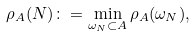<formula> <loc_0><loc_0><loc_500><loc_500>\rho _ { A } ( N ) \colon = \min _ { \omega _ { N } \subset A } \rho _ { A } ( \omega _ { N } ) ,</formula> 